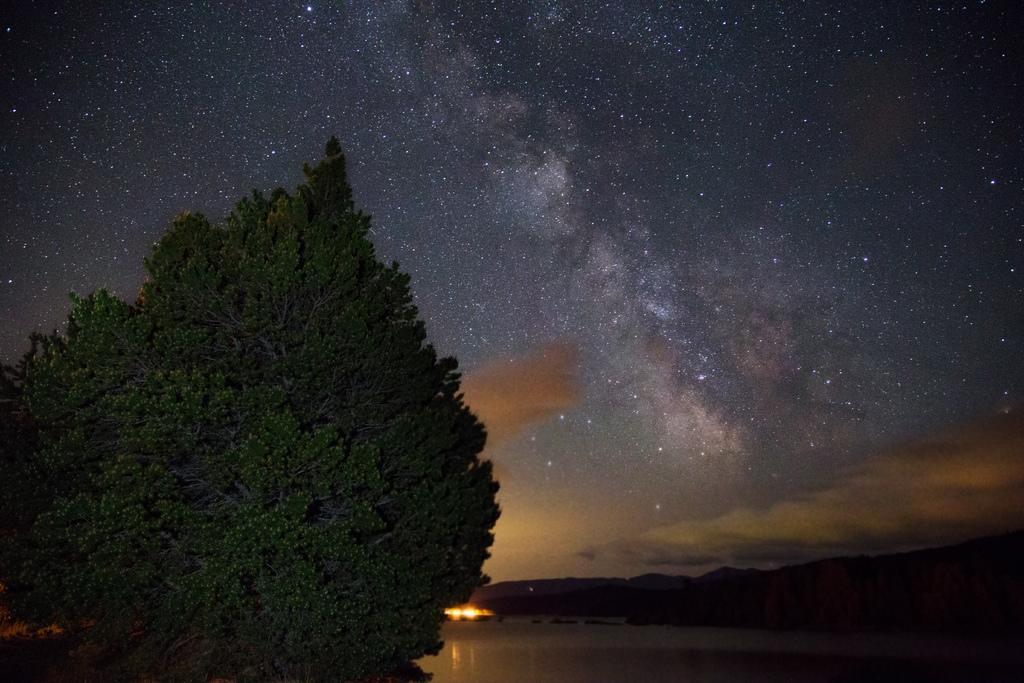Could you give a brief overview of what you see in this image? This image is taken during night time. On the left we can see a tree and on the right there are hills and at the top there is sky with full of stars and at the bottom there is river. 